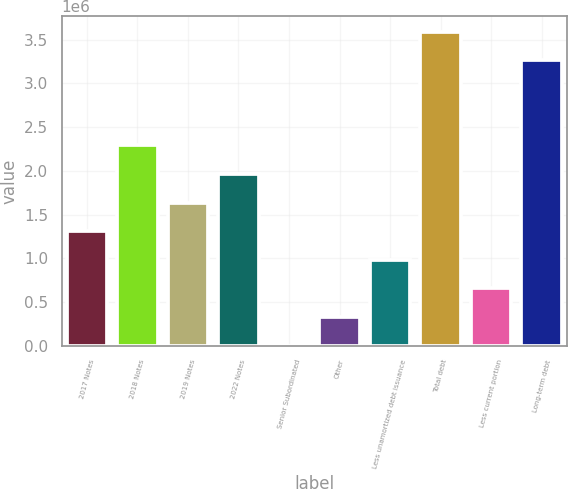<chart> <loc_0><loc_0><loc_500><loc_500><bar_chart><fcel>2017 Notes<fcel>2018 Notes<fcel>2019 Notes<fcel>2022 Notes<fcel>Senior Subordinated<fcel>Other<fcel>Less unamortized debt issuance<fcel>Total debt<fcel>Less current portion<fcel>Long-term debt<nl><fcel>1.311e+06<fcel>2.29111e+06<fcel>1.6377e+06<fcel>1.9644e+06<fcel>4179<fcel>330883<fcel>984292<fcel>3.59112e+06<fcel>657588<fcel>3.26442e+06<nl></chart> 